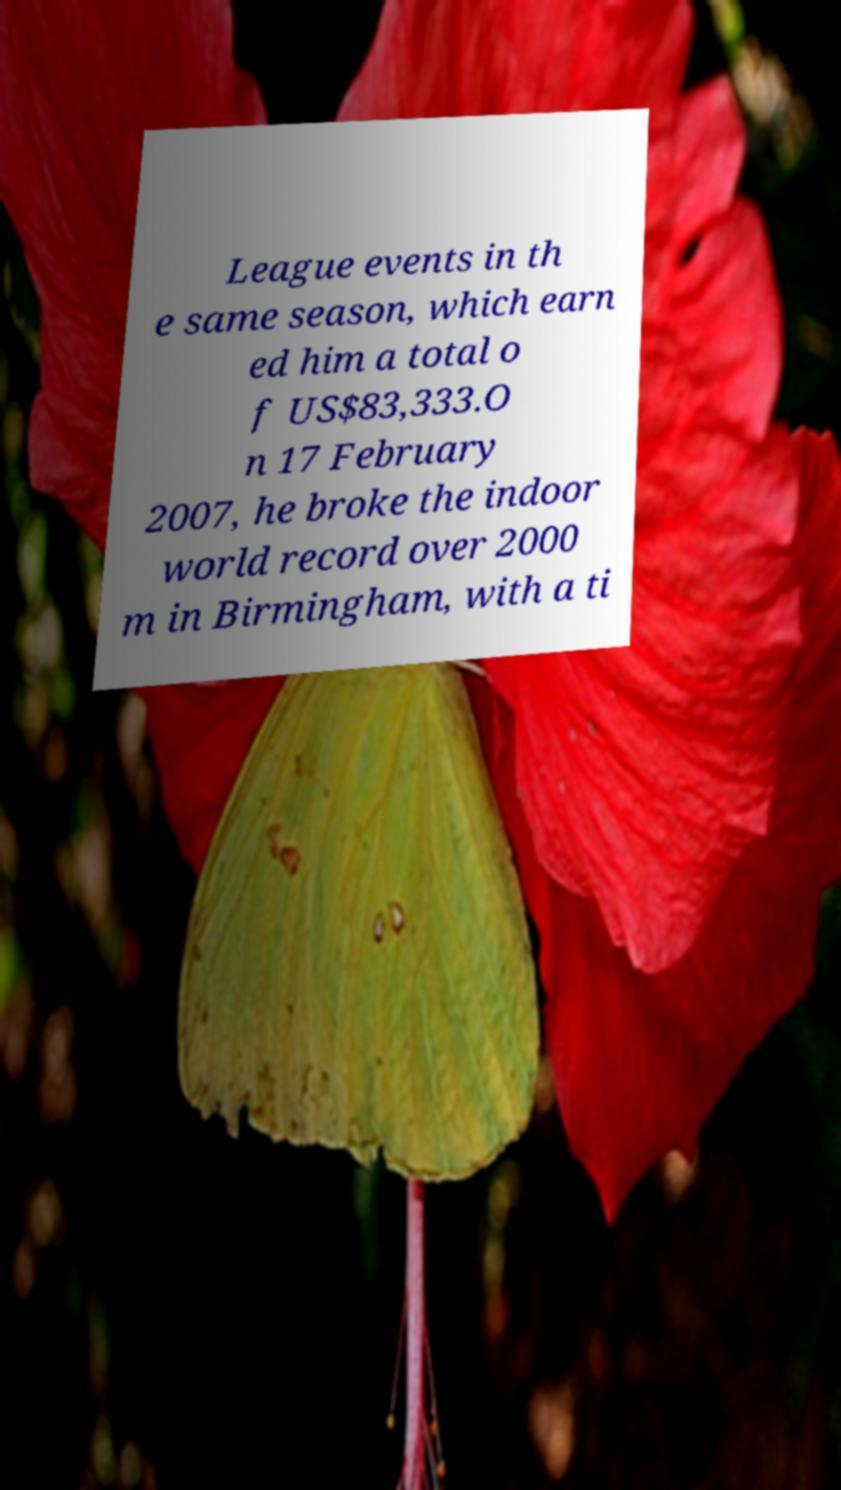Please read and relay the text visible in this image. What does it say? League events in th e same season, which earn ed him a total o f US$83,333.O n 17 February 2007, he broke the indoor world record over 2000 m in Birmingham, with a ti 